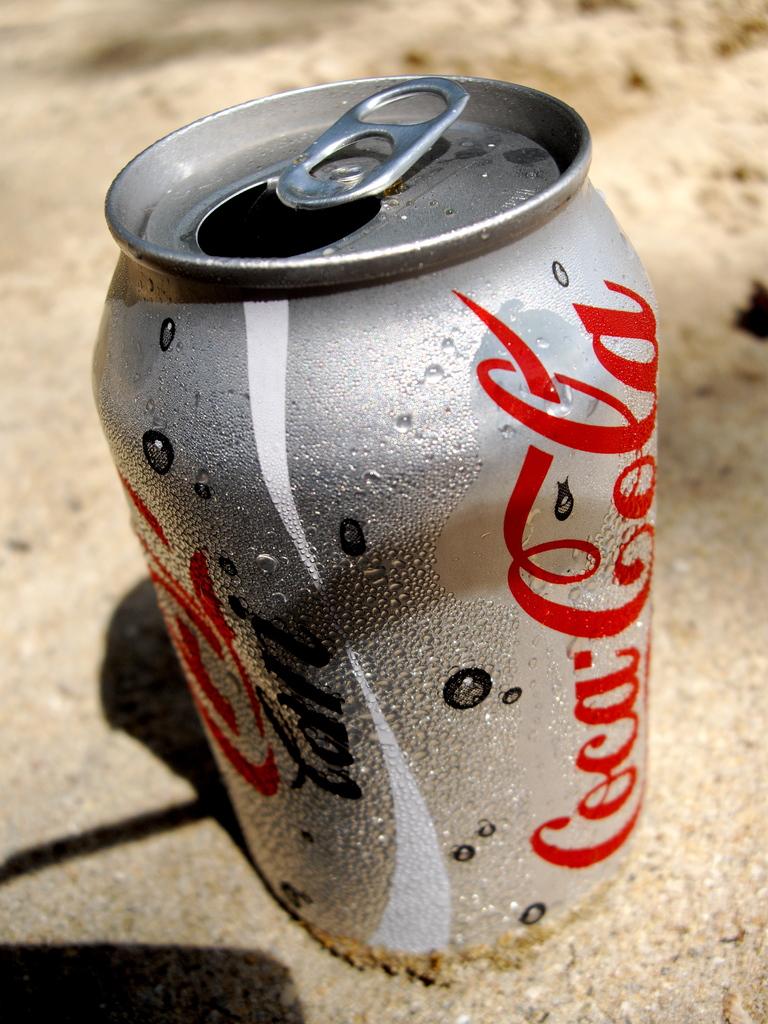Is this diet or regular cola?
Make the answer very short. Diet. 